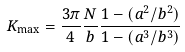Convert formula to latex. <formula><loc_0><loc_0><loc_500><loc_500>K _ { \max } = \frac { 3 \pi } { 4 } \frac { N } { b } \frac { 1 - ( a ^ { 2 } / b ^ { 2 } ) } { 1 - ( a ^ { 3 } / b ^ { 3 } ) }</formula> 